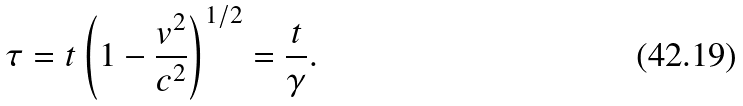Convert formula to latex. <formula><loc_0><loc_0><loc_500><loc_500>\tau = t \left ( 1 - \frac { v ^ { 2 } } { c ^ { 2 } } \right ) ^ { 1 / 2 } = \frac { t } { \gamma } .</formula> 